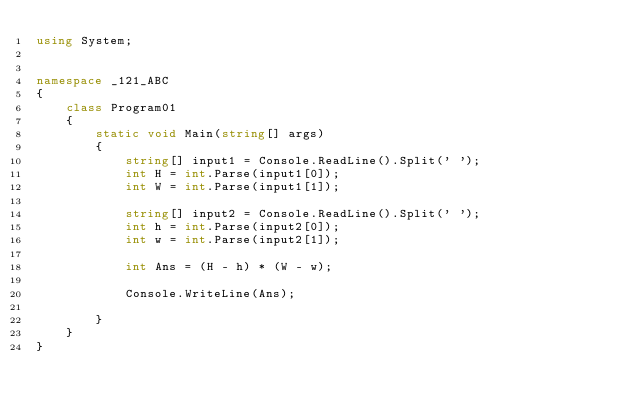Convert code to text. <code><loc_0><loc_0><loc_500><loc_500><_C#_>using System;


namespace _121_ABC
{
    class Program01
    {
        static void Main(string[] args)
        {
            string[] input1 = Console.ReadLine().Split(' ');
            int H = int.Parse(input1[0]);
            int W = int.Parse(input1[1]);

            string[] input2 = Console.ReadLine().Split(' ');
            int h = int.Parse(input2[0]);
            int w = int.Parse(input2[1]);

            int Ans = (H - h) * (W - w);

            Console.WriteLine(Ans);

        }
    }
}
</code> 